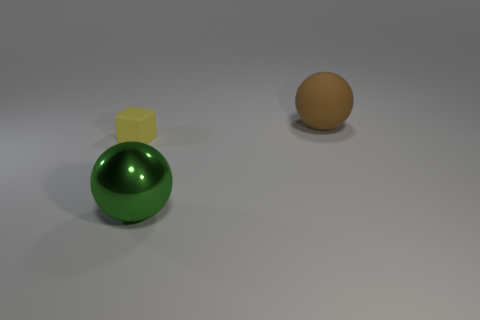Is there any other thing that is made of the same material as the large green object?
Your response must be concise. No. Are there any other things that are the same size as the yellow rubber block?
Provide a succinct answer. No. What is the material of the object behind the tiny yellow rubber thing?
Ensure brevity in your answer.  Rubber. How many other small matte objects are the same shape as the small yellow thing?
Provide a succinct answer. 0. Is the matte ball the same color as the large metal ball?
Keep it short and to the point. No. What material is the ball right of the ball in front of the large sphere behind the big green shiny object?
Offer a terse response. Rubber. Are there any metallic things to the right of the brown matte ball?
Offer a terse response. No. There is a green object that is the same size as the brown rubber thing; what is its shape?
Offer a terse response. Sphere. Does the yellow block have the same material as the big brown ball?
Provide a succinct answer. Yes. How many shiny things are either small red things or big green things?
Ensure brevity in your answer.  1. 